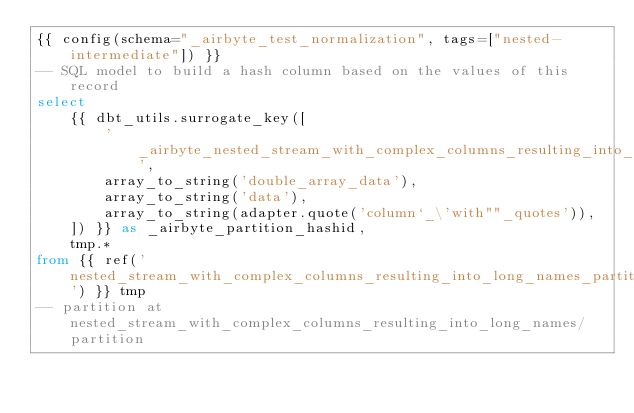<code> <loc_0><loc_0><loc_500><loc_500><_SQL_>{{ config(schema="_airbyte_test_normalization", tags=["nested-intermediate"]) }}
-- SQL model to build a hash column based on the values of this record
select
    {{ dbt_utils.surrogate_key([
        '_airbyte_nested_stream_with_complex_columns_resulting_into_long_names_hashid',
        array_to_string('double_array_data'),
        array_to_string('data'),
        array_to_string(adapter.quote('column`_\'with""_quotes')),
    ]) }} as _airbyte_partition_hashid,
    tmp.*
from {{ ref('nested_stream_with_complex_columns_resulting_into_long_names_partition_ab2') }} tmp
-- partition at nested_stream_with_complex_columns_resulting_into_long_names/partition

</code> 